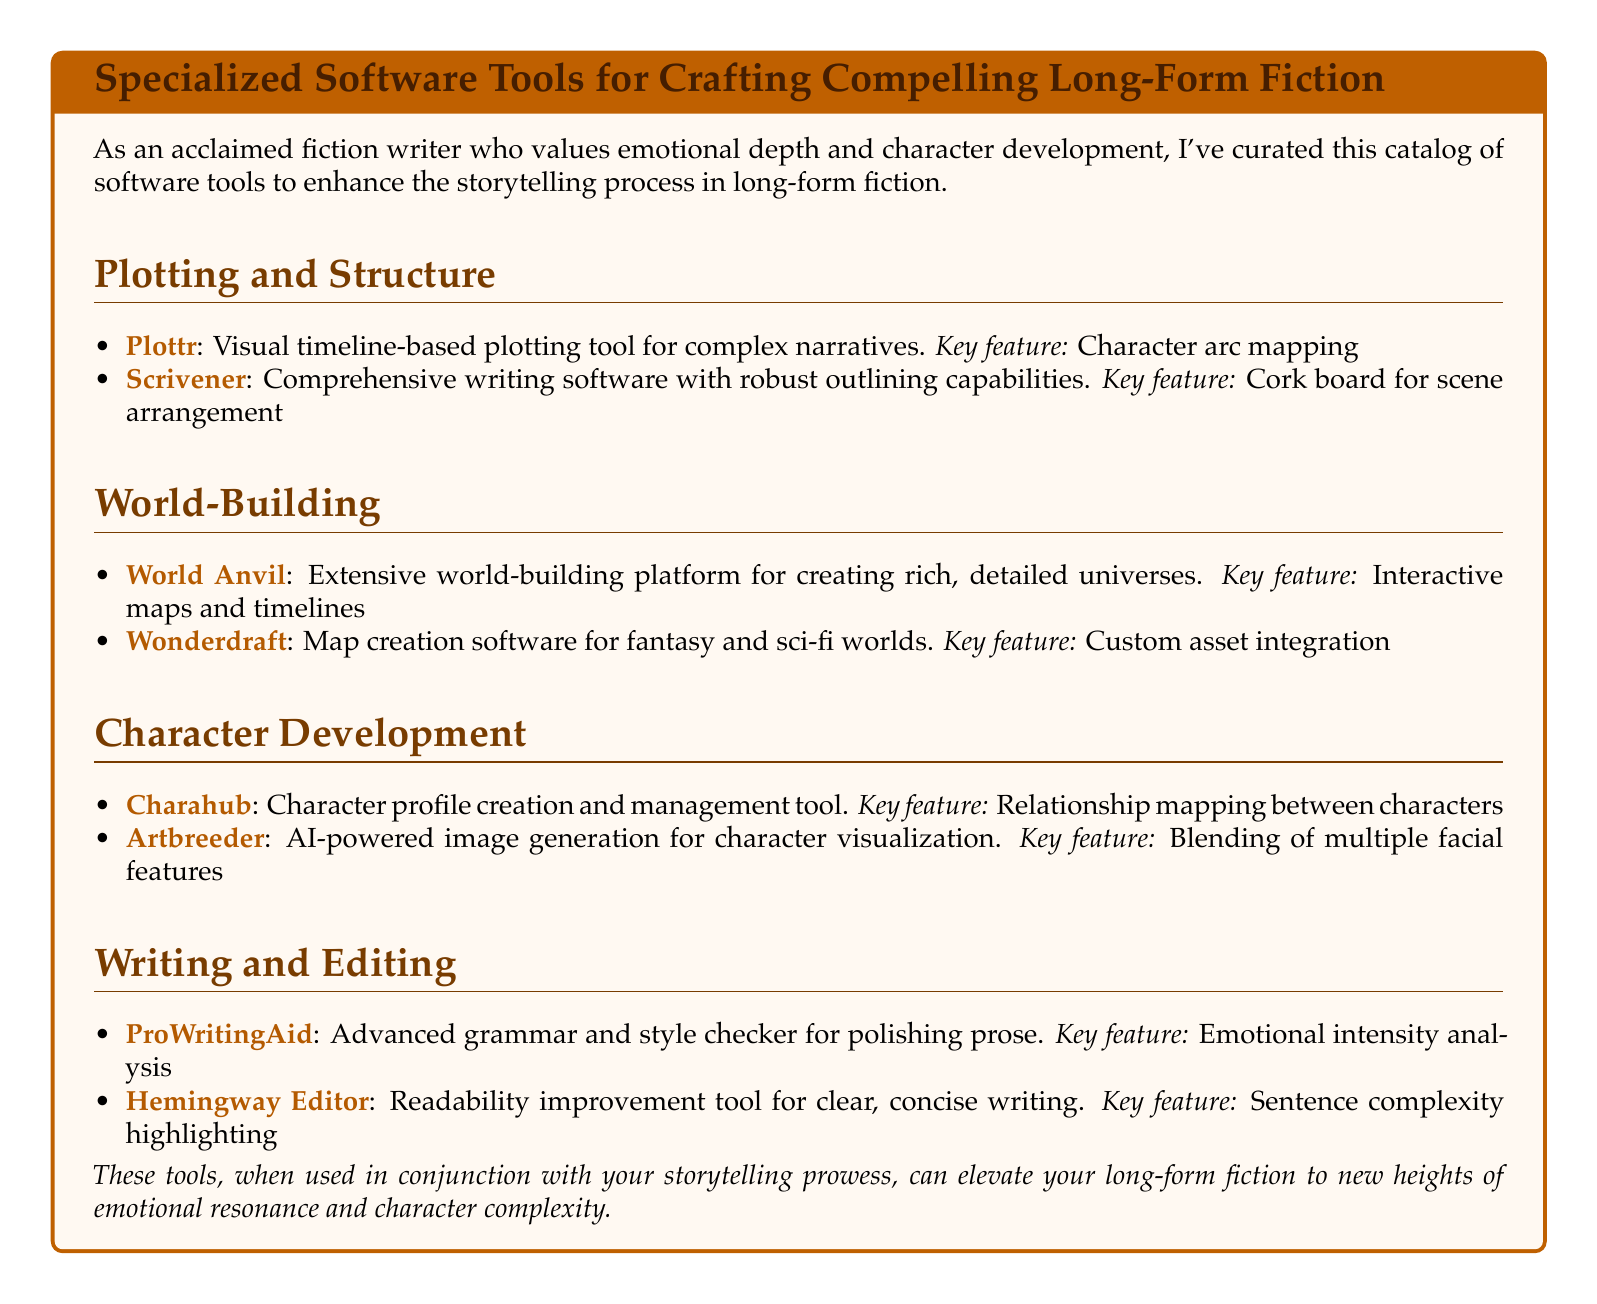What is the name of the visual timeline-based plotting tool? The document lists Plottr as the visual timeline-based plotting tool for complex narratives.
Answer: Plottr What is a key feature of Scrivener? Scrivener's key feature is the cork board for scene arrangement, as stated in the document.
Answer: Cork board for scene arrangement What platform is mentioned for creating interactive maps and timelines? World Anvil is mentioned as an extensive world-building platform for creating rich, detailed universes, including interactive maps and timelines.
Answer: World Anvil How many character development tools are listed in the document? The document lists two character development tools: Charahub and Artbreeder.
Answer: 2 Which tool is designed for emotional intensity analysis? ProWritingAid is specifically noted for its emotional intensity analysis in the document.
Answer: ProWritingAid What type of software is Wonderdraft? Wonderdraft is described as map creation software for fantasy and sci-fi worlds in the document.
Answer: Map creation software What is the primary purpose of the Hemingway Editor? The Hemingway Editor is intended for readability improvement, which is highlighted in the document.
Answer: Readability improvement What tool allows for blending of multiple facial features? Artbreeder is mentioned as the tool that enables blending of multiple facial features for character visualization.
Answer: Artbreeder What color represents the titles in the document? The title color defined in the document is represented by RGB values of (70,30,0).
Answer: RGB(70,30,0) 